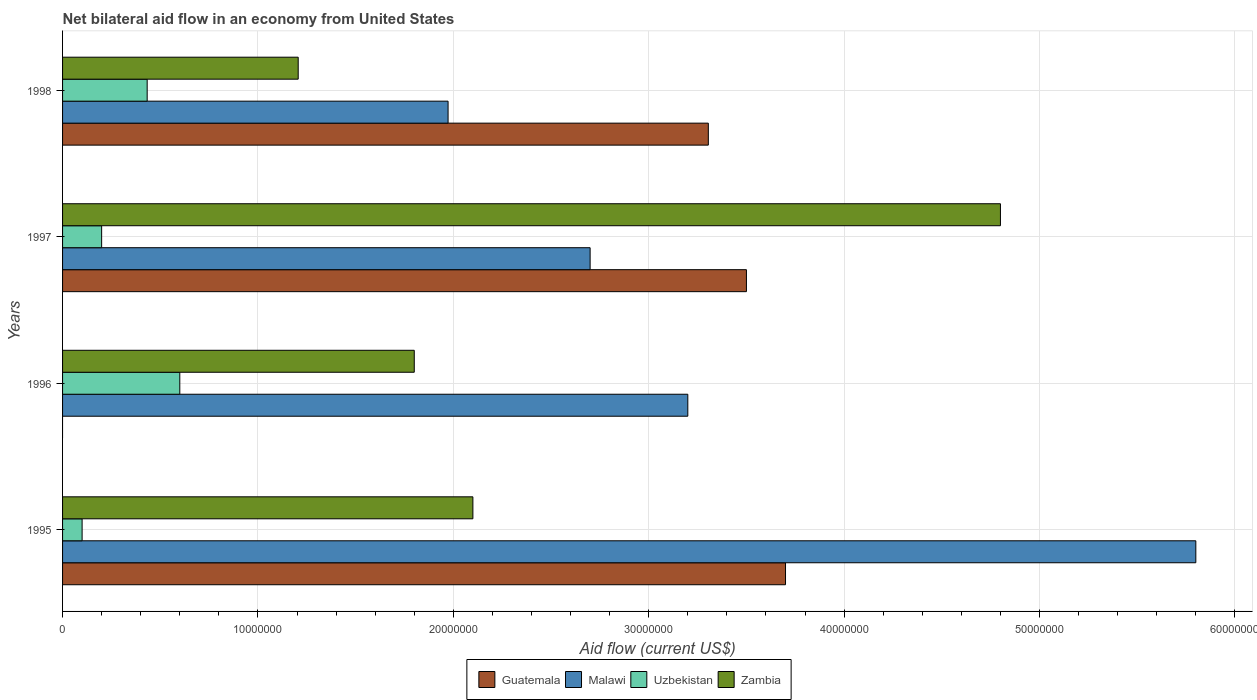How many different coloured bars are there?
Your response must be concise. 4. How many groups of bars are there?
Ensure brevity in your answer.  4. Are the number of bars per tick equal to the number of legend labels?
Provide a succinct answer. No. How many bars are there on the 1st tick from the top?
Offer a very short reply. 4. How many bars are there on the 4th tick from the bottom?
Make the answer very short. 4. In how many cases, is the number of bars for a given year not equal to the number of legend labels?
Give a very brief answer. 1. What is the net bilateral aid flow in Guatemala in 1998?
Keep it short and to the point. 3.30e+07. Across all years, what is the maximum net bilateral aid flow in Uzbekistan?
Give a very brief answer. 6.00e+06. Across all years, what is the minimum net bilateral aid flow in Malawi?
Give a very brief answer. 1.97e+07. In which year was the net bilateral aid flow in Guatemala maximum?
Ensure brevity in your answer.  1995. What is the total net bilateral aid flow in Malawi in the graph?
Give a very brief answer. 1.37e+08. What is the difference between the net bilateral aid flow in Malawi in 1995 and that in 1996?
Ensure brevity in your answer.  2.60e+07. What is the difference between the net bilateral aid flow in Uzbekistan in 1996 and the net bilateral aid flow in Guatemala in 1995?
Your answer should be compact. -3.10e+07. What is the average net bilateral aid flow in Uzbekistan per year?
Offer a very short reply. 3.33e+06. In the year 1998, what is the difference between the net bilateral aid flow in Malawi and net bilateral aid flow in Zambia?
Ensure brevity in your answer.  7.67e+06. In how many years, is the net bilateral aid flow in Zambia greater than 44000000 US$?
Provide a short and direct response. 1. What is the ratio of the net bilateral aid flow in Malawi in 1997 to that in 1998?
Ensure brevity in your answer.  1.37. Is the difference between the net bilateral aid flow in Malawi in 1995 and 1997 greater than the difference between the net bilateral aid flow in Zambia in 1995 and 1997?
Offer a terse response. Yes. What is the difference between the highest and the second highest net bilateral aid flow in Uzbekistan?
Make the answer very short. 1.67e+06. What is the difference between the highest and the lowest net bilateral aid flow in Uzbekistan?
Provide a succinct answer. 5.00e+06. In how many years, is the net bilateral aid flow in Uzbekistan greater than the average net bilateral aid flow in Uzbekistan taken over all years?
Provide a short and direct response. 2. How many bars are there?
Offer a terse response. 15. Are all the bars in the graph horizontal?
Your answer should be compact. Yes. Are the values on the major ticks of X-axis written in scientific E-notation?
Ensure brevity in your answer.  No. Does the graph contain any zero values?
Your answer should be very brief. Yes. Does the graph contain grids?
Offer a terse response. Yes. Where does the legend appear in the graph?
Give a very brief answer. Bottom center. What is the title of the graph?
Make the answer very short. Net bilateral aid flow in an economy from United States. Does "Latin America(all income levels)" appear as one of the legend labels in the graph?
Ensure brevity in your answer.  No. What is the label or title of the X-axis?
Ensure brevity in your answer.  Aid flow (current US$). What is the Aid flow (current US$) of Guatemala in 1995?
Offer a terse response. 3.70e+07. What is the Aid flow (current US$) of Malawi in 1995?
Keep it short and to the point. 5.80e+07. What is the Aid flow (current US$) of Uzbekistan in 1995?
Give a very brief answer. 1.00e+06. What is the Aid flow (current US$) in Zambia in 1995?
Your answer should be very brief. 2.10e+07. What is the Aid flow (current US$) in Guatemala in 1996?
Make the answer very short. 0. What is the Aid flow (current US$) of Malawi in 1996?
Your answer should be compact. 3.20e+07. What is the Aid flow (current US$) in Uzbekistan in 1996?
Provide a short and direct response. 6.00e+06. What is the Aid flow (current US$) of Zambia in 1996?
Ensure brevity in your answer.  1.80e+07. What is the Aid flow (current US$) in Guatemala in 1997?
Make the answer very short. 3.50e+07. What is the Aid flow (current US$) of Malawi in 1997?
Your response must be concise. 2.70e+07. What is the Aid flow (current US$) of Uzbekistan in 1997?
Provide a short and direct response. 2.00e+06. What is the Aid flow (current US$) of Zambia in 1997?
Ensure brevity in your answer.  4.80e+07. What is the Aid flow (current US$) in Guatemala in 1998?
Keep it short and to the point. 3.30e+07. What is the Aid flow (current US$) in Malawi in 1998?
Your response must be concise. 1.97e+07. What is the Aid flow (current US$) of Uzbekistan in 1998?
Offer a very short reply. 4.33e+06. What is the Aid flow (current US$) in Zambia in 1998?
Provide a short and direct response. 1.21e+07. Across all years, what is the maximum Aid flow (current US$) in Guatemala?
Your response must be concise. 3.70e+07. Across all years, what is the maximum Aid flow (current US$) in Malawi?
Your answer should be very brief. 5.80e+07. Across all years, what is the maximum Aid flow (current US$) of Uzbekistan?
Offer a terse response. 6.00e+06. Across all years, what is the maximum Aid flow (current US$) of Zambia?
Your response must be concise. 4.80e+07. Across all years, what is the minimum Aid flow (current US$) of Malawi?
Your answer should be compact. 1.97e+07. Across all years, what is the minimum Aid flow (current US$) in Uzbekistan?
Offer a very short reply. 1.00e+06. Across all years, what is the minimum Aid flow (current US$) in Zambia?
Keep it short and to the point. 1.21e+07. What is the total Aid flow (current US$) in Guatemala in the graph?
Keep it short and to the point. 1.05e+08. What is the total Aid flow (current US$) of Malawi in the graph?
Provide a short and direct response. 1.37e+08. What is the total Aid flow (current US$) in Uzbekistan in the graph?
Provide a short and direct response. 1.33e+07. What is the total Aid flow (current US$) of Zambia in the graph?
Provide a short and direct response. 9.91e+07. What is the difference between the Aid flow (current US$) in Malawi in 1995 and that in 1996?
Your answer should be compact. 2.60e+07. What is the difference between the Aid flow (current US$) of Uzbekistan in 1995 and that in 1996?
Offer a terse response. -5.00e+06. What is the difference between the Aid flow (current US$) of Zambia in 1995 and that in 1996?
Keep it short and to the point. 3.00e+06. What is the difference between the Aid flow (current US$) of Guatemala in 1995 and that in 1997?
Keep it short and to the point. 2.00e+06. What is the difference between the Aid flow (current US$) in Malawi in 1995 and that in 1997?
Keep it short and to the point. 3.10e+07. What is the difference between the Aid flow (current US$) of Zambia in 1995 and that in 1997?
Offer a terse response. -2.70e+07. What is the difference between the Aid flow (current US$) of Guatemala in 1995 and that in 1998?
Offer a very short reply. 3.95e+06. What is the difference between the Aid flow (current US$) of Malawi in 1995 and that in 1998?
Provide a short and direct response. 3.83e+07. What is the difference between the Aid flow (current US$) in Uzbekistan in 1995 and that in 1998?
Your response must be concise. -3.33e+06. What is the difference between the Aid flow (current US$) of Zambia in 1995 and that in 1998?
Make the answer very short. 8.94e+06. What is the difference between the Aid flow (current US$) in Malawi in 1996 and that in 1997?
Provide a short and direct response. 5.00e+06. What is the difference between the Aid flow (current US$) of Uzbekistan in 1996 and that in 1997?
Give a very brief answer. 4.00e+06. What is the difference between the Aid flow (current US$) of Zambia in 1996 and that in 1997?
Keep it short and to the point. -3.00e+07. What is the difference between the Aid flow (current US$) of Malawi in 1996 and that in 1998?
Offer a terse response. 1.23e+07. What is the difference between the Aid flow (current US$) of Uzbekistan in 1996 and that in 1998?
Provide a short and direct response. 1.67e+06. What is the difference between the Aid flow (current US$) in Zambia in 1996 and that in 1998?
Your response must be concise. 5.94e+06. What is the difference between the Aid flow (current US$) of Guatemala in 1997 and that in 1998?
Provide a succinct answer. 1.95e+06. What is the difference between the Aid flow (current US$) of Malawi in 1997 and that in 1998?
Provide a succinct answer. 7.27e+06. What is the difference between the Aid flow (current US$) of Uzbekistan in 1997 and that in 1998?
Keep it short and to the point. -2.33e+06. What is the difference between the Aid flow (current US$) in Zambia in 1997 and that in 1998?
Provide a succinct answer. 3.59e+07. What is the difference between the Aid flow (current US$) in Guatemala in 1995 and the Aid flow (current US$) in Uzbekistan in 1996?
Give a very brief answer. 3.10e+07. What is the difference between the Aid flow (current US$) of Guatemala in 1995 and the Aid flow (current US$) of Zambia in 1996?
Ensure brevity in your answer.  1.90e+07. What is the difference between the Aid flow (current US$) in Malawi in 1995 and the Aid flow (current US$) in Uzbekistan in 1996?
Provide a short and direct response. 5.20e+07. What is the difference between the Aid flow (current US$) in Malawi in 1995 and the Aid flow (current US$) in Zambia in 1996?
Keep it short and to the point. 4.00e+07. What is the difference between the Aid flow (current US$) in Uzbekistan in 1995 and the Aid flow (current US$) in Zambia in 1996?
Provide a short and direct response. -1.70e+07. What is the difference between the Aid flow (current US$) of Guatemala in 1995 and the Aid flow (current US$) of Malawi in 1997?
Keep it short and to the point. 1.00e+07. What is the difference between the Aid flow (current US$) of Guatemala in 1995 and the Aid flow (current US$) of Uzbekistan in 1997?
Offer a terse response. 3.50e+07. What is the difference between the Aid flow (current US$) in Guatemala in 1995 and the Aid flow (current US$) in Zambia in 1997?
Your response must be concise. -1.10e+07. What is the difference between the Aid flow (current US$) of Malawi in 1995 and the Aid flow (current US$) of Uzbekistan in 1997?
Ensure brevity in your answer.  5.60e+07. What is the difference between the Aid flow (current US$) in Malawi in 1995 and the Aid flow (current US$) in Zambia in 1997?
Your response must be concise. 1.00e+07. What is the difference between the Aid flow (current US$) of Uzbekistan in 1995 and the Aid flow (current US$) of Zambia in 1997?
Make the answer very short. -4.70e+07. What is the difference between the Aid flow (current US$) in Guatemala in 1995 and the Aid flow (current US$) in Malawi in 1998?
Your response must be concise. 1.73e+07. What is the difference between the Aid flow (current US$) in Guatemala in 1995 and the Aid flow (current US$) in Uzbekistan in 1998?
Your response must be concise. 3.27e+07. What is the difference between the Aid flow (current US$) of Guatemala in 1995 and the Aid flow (current US$) of Zambia in 1998?
Your answer should be compact. 2.49e+07. What is the difference between the Aid flow (current US$) in Malawi in 1995 and the Aid flow (current US$) in Uzbekistan in 1998?
Your response must be concise. 5.37e+07. What is the difference between the Aid flow (current US$) in Malawi in 1995 and the Aid flow (current US$) in Zambia in 1998?
Offer a very short reply. 4.59e+07. What is the difference between the Aid flow (current US$) in Uzbekistan in 1995 and the Aid flow (current US$) in Zambia in 1998?
Your response must be concise. -1.11e+07. What is the difference between the Aid flow (current US$) of Malawi in 1996 and the Aid flow (current US$) of Uzbekistan in 1997?
Ensure brevity in your answer.  3.00e+07. What is the difference between the Aid flow (current US$) of Malawi in 1996 and the Aid flow (current US$) of Zambia in 1997?
Provide a short and direct response. -1.60e+07. What is the difference between the Aid flow (current US$) in Uzbekistan in 1996 and the Aid flow (current US$) in Zambia in 1997?
Your answer should be very brief. -4.20e+07. What is the difference between the Aid flow (current US$) in Malawi in 1996 and the Aid flow (current US$) in Uzbekistan in 1998?
Provide a short and direct response. 2.77e+07. What is the difference between the Aid flow (current US$) of Malawi in 1996 and the Aid flow (current US$) of Zambia in 1998?
Your answer should be very brief. 1.99e+07. What is the difference between the Aid flow (current US$) of Uzbekistan in 1996 and the Aid flow (current US$) of Zambia in 1998?
Provide a succinct answer. -6.06e+06. What is the difference between the Aid flow (current US$) in Guatemala in 1997 and the Aid flow (current US$) in Malawi in 1998?
Offer a very short reply. 1.53e+07. What is the difference between the Aid flow (current US$) in Guatemala in 1997 and the Aid flow (current US$) in Uzbekistan in 1998?
Give a very brief answer. 3.07e+07. What is the difference between the Aid flow (current US$) in Guatemala in 1997 and the Aid flow (current US$) in Zambia in 1998?
Provide a succinct answer. 2.29e+07. What is the difference between the Aid flow (current US$) in Malawi in 1997 and the Aid flow (current US$) in Uzbekistan in 1998?
Your answer should be compact. 2.27e+07. What is the difference between the Aid flow (current US$) of Malawi in 1997 and the Aid flow (current US$) of Zambia in 1998?
Provide a short and direct response. 1.49e+07. What is the difference between the Aid flow (current US$) in Uzbekistan in 1997 and the Aid flow (current US$) in Zambia in 1998?
Ensure brevity in your answer.  -1.01e+07. What is the average Aid flow (current US$) of Guatemala per year?
Provide a short and direct response. 2.63e+07. What is the average Aid flow (current US$) in Malawi per year?
Make the answer very short. 3.42e+07. What is the average Aid flow (current US$) in Uzbekistan per year?
Your response must be concise. 3.33e+06. What is the average Aid flow (current US$) in Zambia per year?
Your answer should be compact. 2.48e+07. In the year 1995, what is the difference between the Aid flow (current US$) in Guatemala and Aid flow (current US$) in Malawi?
Make the answer very short. -2.10e+07. In the year 1995, what is the difference between the Aid flow (current US$) in Guatemala and Aid flow (current US$) in Uzbekistan?
Your response must be concise. 3.60e+07. In the year 1995, what is the difference between the Aid flow (current US$) in Guatemala and Aid flow (current US$) in Zambia?
Ensure brevity in your answer.  1.60e+07. In the year 1995, what is the difference between the Aid flow (current US$) in Malawi and Aid flow (current US$) in Uzbekistan?
Keep it short and to the point. 5.70e+07. In the year 1995, what is the difference between the Aid flow (current US$) of Malawi and Aid flow (current US$) of Zambia?
Offer a terse response. 3.70e+07. In the year 1995, what is the difference between the Aid flow (current US$) in Uzbekistan and Aid flow (current US$) in Zambia?
Your answer should be compact. -2.00e+07. In the year 1996, what is the difference between the Aid flow (current US$) of Malawi and Aid flow (current US$) of Uzbekistan?
Offer a very short reply. 2.60e+07. In the year 1996, what is the difference between the Aid flow (current US$) of Malawi and Aid flow (current US$) of Zambia?
Ensure brevity in your answer.  1.40e+07. In the year 1996, what is the difference between the Aid flow (current US$) of Uzbekistan and Aid flow (current US$) of Zambia?
Make the answer very short. -1.20e+07. In the year 1997, what is the difference between the Aid flow (current US$) of Guatemala and Aid flow (current US$) of Uzbekistan?
Offer a terse response. 3.30e+07. In the year 1997, what is the difference between the Aid flow (current US$) in Guatemala and Aid flow (current US$) in Zambia?
Your answer should be compact. -1.30e+07. In the year 1997, what is the difference between the Aid flow (current US$) in Malawi and Aid flow (current US$) in Uzbekistan?
Offer a very short reply. 2.50e+07. In the year 1997, what is the difference between the Aid flow (current US$) of Malawi and Aid flow (current US$) of Zambia?
Ensure brevity in your answer.  -2.10e+07. In the year 1997, what is the difference between the Aid flow (current US$) in Uzbekistan and Aid flow (current US$) in Zambia?
Your answer should be very brief. -4.60e+07. In the year 1998, what is the difference between the Aid flow (current US$) in Guatemala and Aid flow (current US$) in Malawi?
Provide a succinct answer. 1.33e+07. In the year 1998, what is the difference between the Aid flow (current US$) in Guatemala and Aid flow (current US$) in Uzbekistan?
Your response must be concise. 2.87e+07. In the year 1998, what is the difference between the Aid flow (current US$) in Guatemala and Aid flow (current US$) in Zambia?
Your answer should be very brief. 2.10e+07. In the year 1998, what is the difference between the Aid flow (current US$) of Malawi and Aid flow (current US$) of Uzbekistan?
Provide a succinct answer. 1.54e+07. In the year 1998, what is the difference between the Aid flow (current US$) of Malawi and Aid flow (current US$) of Zambia?
Make the answer very short. 7.67e+06. In the year 1998, what is the difference between the Aid flow (current US$) of Uzbekistan and Aid flow (current US$) of Zambia?
Offer a terse response. -7.73e+06. What is the ratio of the Aid flow (current US$) in Malawi in 1995 to that in 1996?
Your answer should be compact. 1.81. What is the ratio of the Aid flow (current US$) in Guatemala in 1995 to that in 1997?
Offer a terse response. 1.06. What is the ratio of the Aid flow (current US$) in Malawi in 1995 to that in 1997?
Provide a succinct answer. 2.15. What is the ratio of the Aid flow (current US$) in Zambia in 1995 to that in 1997?
Keep it short and to the point. 0.44. What is the ratio of the Aid flow (current US$) in Guatemala in 1995 to that in 1998?
Your answer should be compact. 1.12. What is the ratio of the Aid flow (current US$) in Malawi in 1995 to that in 1998?
Offer a terse response. 2.94. What is the ratio of the Aid flow (current US$) of Uzbekistan in 1995 to that in 1998?
Offer a very short reply. 0.23. What is the ratio of the Aid flow (current US$) of Zambia in 1995 to that in 1998?
Your answer should be compact. 1.74. What is the ratio of the Aid flow (current US$) in Malawi in 1996 to that in 1997?
Your answer should be compact. 1.19. What is the ratio of the Aid flow (current US$) in Zambia in 1996 to that in 1997?
Your response must be concise. 0.38. What is the ratio of the Aid flow (current US$) in Malawi in 1996 to that in 1998?
Provide a short and direct response. 1.62. What is the ratio of the Aid flow (current US$) in Uzbekistan in 1996 to that in 1998?
Keep it short and to the point. 1.39. What is the ratio of the Aid flow (current US$) in Zambia in 1996 to that in 1998?
Your response must be concise. 1.49. What is the ratio of the Aid flow (current US$) of Guatemala in 1997 to that in 1998?
Give a very brief answer. 1.06. What is the ratio of the Aid flow (current US$) of Malawi in 1997 to that in 1998?
Ensure brevity in your answer.  1.37. What is the ratio of the Aid flow (current US$) in Uzbekistan in 1997 to that in 1998?
Offer a very short reply. 0.46. What is the ratio of the Aid flow (current US$) of Zambia in 1997 to that in 1998?
Your answer should be compact. 3.98. What is the difference between the highest and the second highest Aid flow (current US$) in Malawi?
Offer a terse response. 2.60e+07. What is the difference between the highest and the second highest Aid flow (current US$) of Uzbekistan?
Ensure brevity in your answer.  1.67e+06. What is the difference between the highest and the second highest Aid flow (current US$) in Zambia?
Your answer should be very brief. 2.70e+07. What is the difference between the highest and the lowest Aid flow (current US$) in Guatemala?
Provide a short and direct response. 3.70e+07. What is the difference between the highest and the lowest Aid flow (current US$) in Malawi?
Offer a very short reply. 3.83e+07. What is the difference between the highest and the lowest Aid flow (current US$) of Uzbekistan?
Your answer should be very brief. 5.00e+06. What is the difference between the highest and the lowest Aid flow (current US$) in Zambia?
Your answer should be compact. 3.59e+07. 